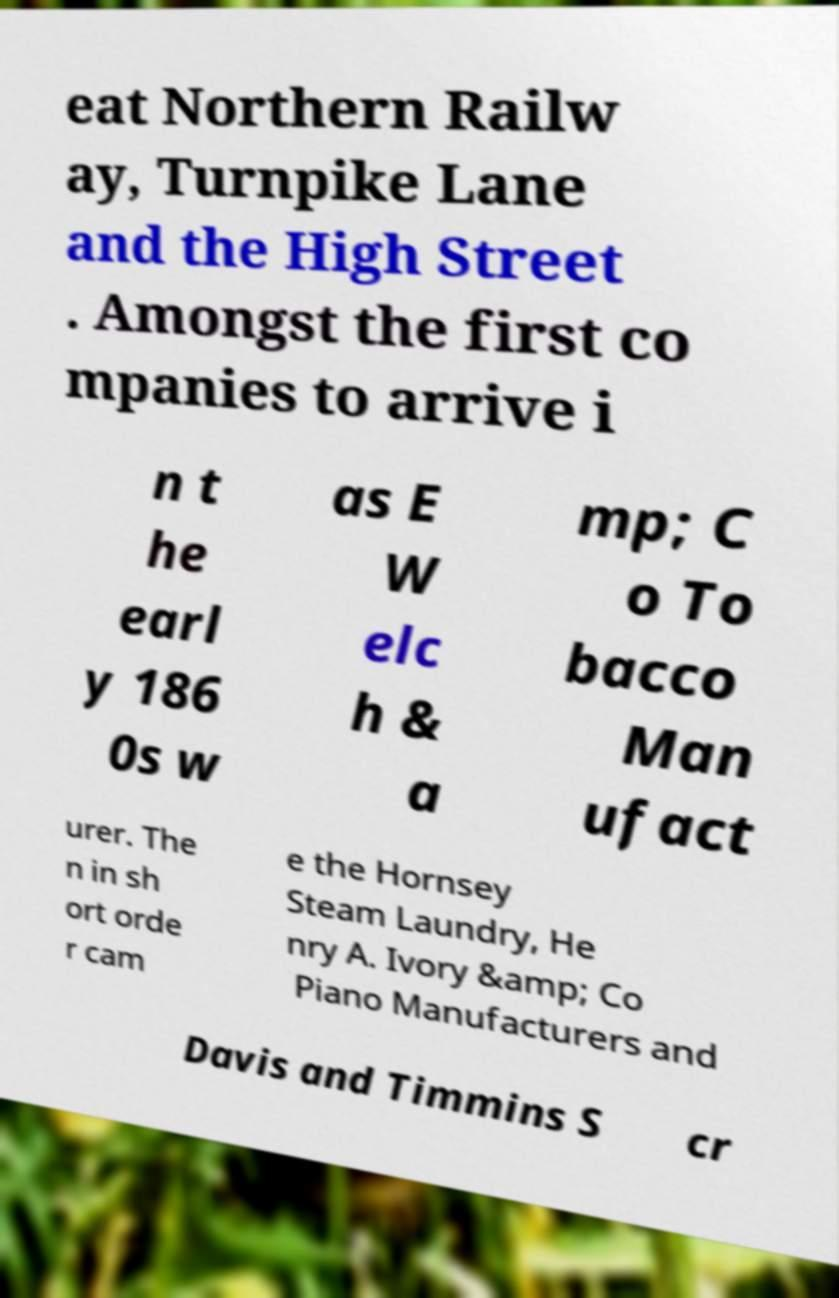Could you assist in decoding the text presented in this image and type it out clearly? eat Northern Railw ay, Turnpike Lane and the High Street . Amongst the first co mpanies to arrive i n t he earl y 186 0s w as E W elc h & a mp; C o To bacco Man ufact urer. The n in sh ort orde r cam e the Hornsey Steam Laundry, He nry A. Ivory &amp; Co Piano Manufacturers and Davis and Timmins S cr 